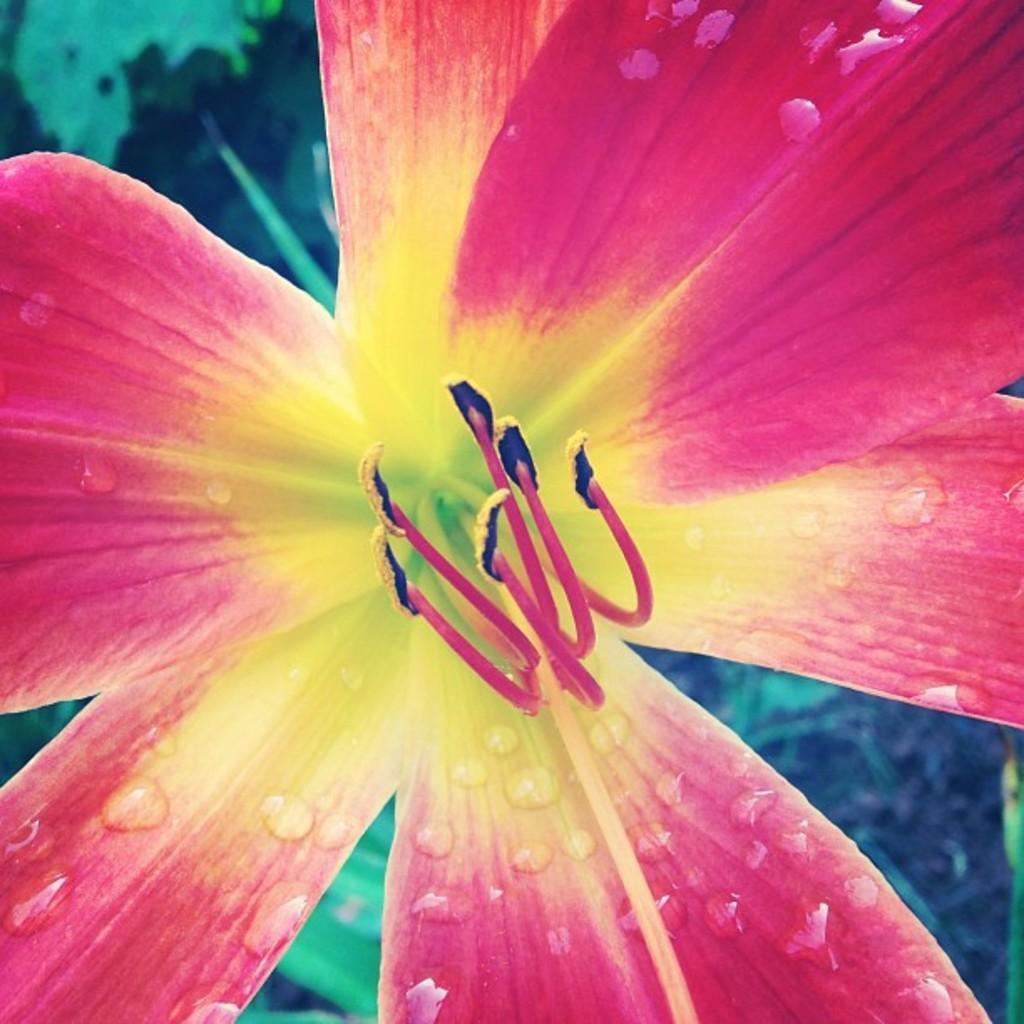Describe this image in one or two sentences. In this picture I can see a flower and I can see blurry background. 